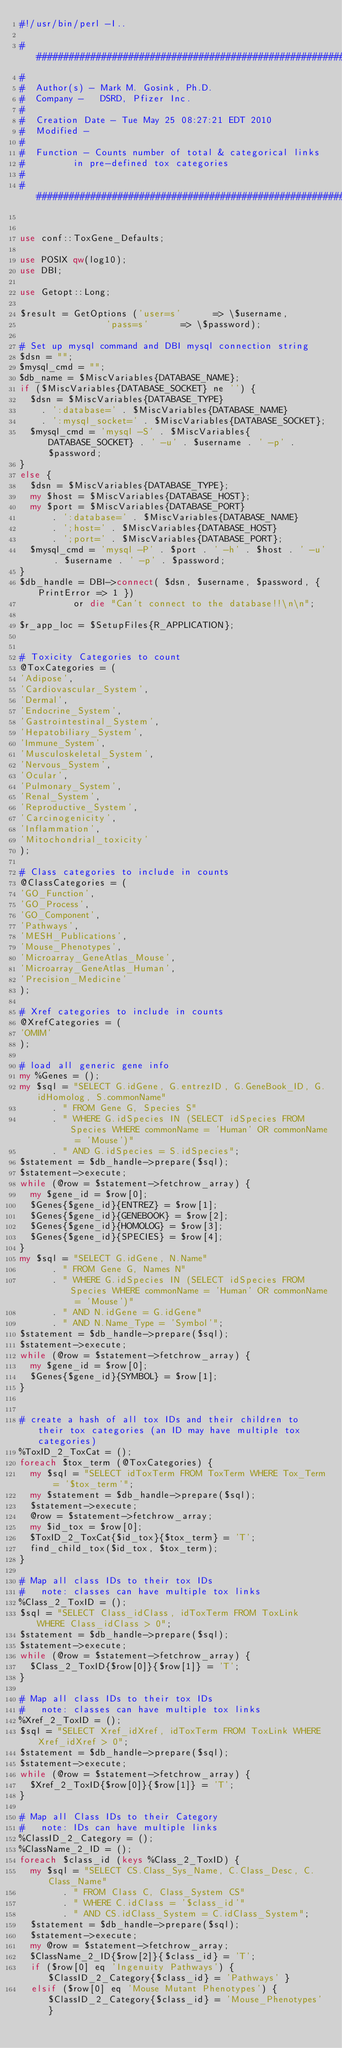<code> <loc_0><loc_0><loc_500><loc_500><_Perl_>#!/usr/bin/perl -I..

################################################################
#
#  Author(s) - Mark M. Gosink, Ph.D.
#  Company -   DSRD, Pfizer Inc.
#
#  Creation Date - Tue May 25 08:27:21 EDT 2010
#  Modified - 
#
#  Function - Counts number of total & categorical links
#					in pre-defined tox categories
#
################################################################


use conf::ToxGene_Defaults;

use POSIX qw(log10);
use DBI;

use Getopt::Long;

$result = GetOptions ('user=s'			=> \$username,
								'pass=s'			=> \$password);

#	Set up mysql command and DBI mysql connection string
$dsn = "";
$mysql_cmd = "";
$db_name = $MiscVariables{DATABASE_NAME};
if ($MiscVariables{DATABASE_SOCKET} ne '') {
	$dsn = $MiscVariables{DATABASE_TYPE}
		. ':database=' . $MiscVariables{DATABASE_NAME}
		. ':mysql_socket=' . $MiscVariables{DATABASE_SOCKET};
	$mysql_cmd = 'mysql -S' . $MiscVariables{DATABASE_SOCKET} . ' -u' . $username . ' -p' . $password;
}
else {
	$dsn = $MiscVariables{DATABASE_TYPE};
	my $host = $MiscVariables{DATABASE_HOST};
	my $port = $MiscVariables{DATABASE_PORT}
			. ':database=' . $MiscVariables{DATABASE_NAME}
			. ';host=' . $MiscVariables{DATABASE_HOST}
			. ';port=' . $MiscVariables{DATABASE_PORT};
	$mysql_cmd = 'mysql -P' . $port . ' -h' . $host . ' -u' . $username . ' -p' . $password;
}
$db_handle = DBI->connect( $dsn, $username, $password, { PrintError => 1 })
					or die "Can't connect to the database!!\n\n";

$r_app_loc = $SetupFiles{R_APPLICATION};


#	Toxicity Categories to count
@ToxCategories = (
'Adipose',
'Cardiovascular_System',
'Dermal',
'Endocrine_System',
'Gastrointestinal_System',
'Hepatobiliary_System',
'Immune_System',
'Musculoskeletal_System',
'Nervous_System',
'Ocular',
'Pulmonary_System',
'Renal_System',
'Reproductive_System',
'Carcinogenicity',
'Inflammation',
'Mitochondrial_toxicity'
);

#	Class categories to include in counts
@ClassCategories = (
'GO_Function',
'GO_Process',
'GO_Component',
'Pathways',
'MESH_Publications',
'Mouse_Phenotypes',
'Microarray_GeneAtlas_Mouse',
'Microarray_GeneAtlas_Human',
'Precision_Medicine'
);

#	Xref categories to include in counts
@XrefCategories = (
'OMIM'
);

#	load all generic gene info
my %Genes = ();
my $sql = "SELECT G.idGene, G.entrezID, G.GeneBook_ID, G.idHomolog, S.commonName"
			. " FROM Gene G, Species S"
			. " WHERE G.idSpecies IN (SELECT idSpecies FROM Species WHERE commonName = 'Human' OR commonName = 'Mouse')"
			. " AND G.idSpecies = S.idSpecies";
$statement = $db_handle->prepare($sql);
$statement->execute;
while (@row = $statement->fetchrow_array) {
	my $gene_id = $row[0];
	$Genes{$gene_id}{ENTREZ} = $row[1];
	$Genes{$gene_id}{GENEBOOK} = $row[2];
	$Genes{$gene_id}{HOMOLOG} = $row[3];
	$Genes{$gene_id}{SPECIES} = $row[4];
}
my $sql = "SELECT G.idGene, N.Name"
			. " FROM Gene G, Names N"
			. " WHERE G.idSpecies IN (SELECT idSpecies FROM Species WHERE commonName = 'Human' OR commonName = 'Mouse')"
			. " AND N.idGene = G.idGene"
			. " AND N.Name_Type = 'Symbol'";
$statement = $db_handle->prepare($sql);
$statement->execute;
while (@row = $statement->fetchrow_array) {
	my $gene_id = $row[0];
	$Genes{$gene_id}{SYMBOL} = $row[1];
}


#	create a hash of all tox IDs and their children to their tox categories (an ID may have multiple tox categories)
%ToxID_2_ToxCat = ();
foreach $tox_term (@ToxCategories) {
	my $sql = "SELECT idToxTerm FROM ToxTerm WHERE Tox_Term = '$tox_term'";
	my $statement = $db_handle->prepare($sql);
	$statement->execute;
	@row = $statement->fetchrow_array;
	my $id_tox = $row[0];
	$ToxID_2_ToxCat{$id_tox}{$tox_term} = 'T';
	find_child_tox($id_tox, $tox_term);
}

#	Map all class IDs to their tox IDs
#		note: classes can have multiple tox links
%Class_2_ToxID = ();
$sql = "SELECT Class_idClass, idToxTerm FROM ToxLink WHERE Class_idClass > 0";
$statement = $db_handle->prepare($sql);
$statement->execute;
while (@row = $statement->fetchrow_array) {
	$Class_2_ToxID{$row[0]}{$row[1]} = 'T';
}

#	Map all class IDs to their tox IDs
#		note: classes can have multiple tox links
%Xref_2_ToxID = ();
$sql = "SELECT Xref_idXref, idToxTerm FROM ToxLink WHERE Xref_idXref > 0";
$statement = $db_handle->prepare($sql);
$statement->execute;
while (@row = $statement->fetchrow_array) {
	$Xref_2_ToxID{$row[0]}{$row[1]} = 'T';
}

#	Map all Class IDs to their Category
#		note: IDs can have multiple links
%ClassID_2_Category = ();
%ClassName_2_ID = ();
foreach $class_id (keys %Class_2_ToxID) {
	my $sql = "SELECT CS.Class_Sys_Name, C.Class_Desc, C.Class_Name"
				. " FROM Class C, Class_System CS"
				. " WHERE C.idClass = '$class_id'"
				. " AND CS.idClass_System = C.idClass_System";
	$statement = $db_handle->prepare($sql);
	$statement->execute;
	my @row = $statement->fetchrow_array;
	$ClassName_2_ID{$row[2]}{$class_id} = 'T';
	if ($row[0] eq 'Ingenuity Pathways') { $ClassID_2_Category{$class_id} = 'Pathways' }
	elsif ($row[0] eq 'Mouse Mutant Phenotypes') { $ClassID_2_Category{$class_id} = 'Mouse_Phenotypes' }</code> 